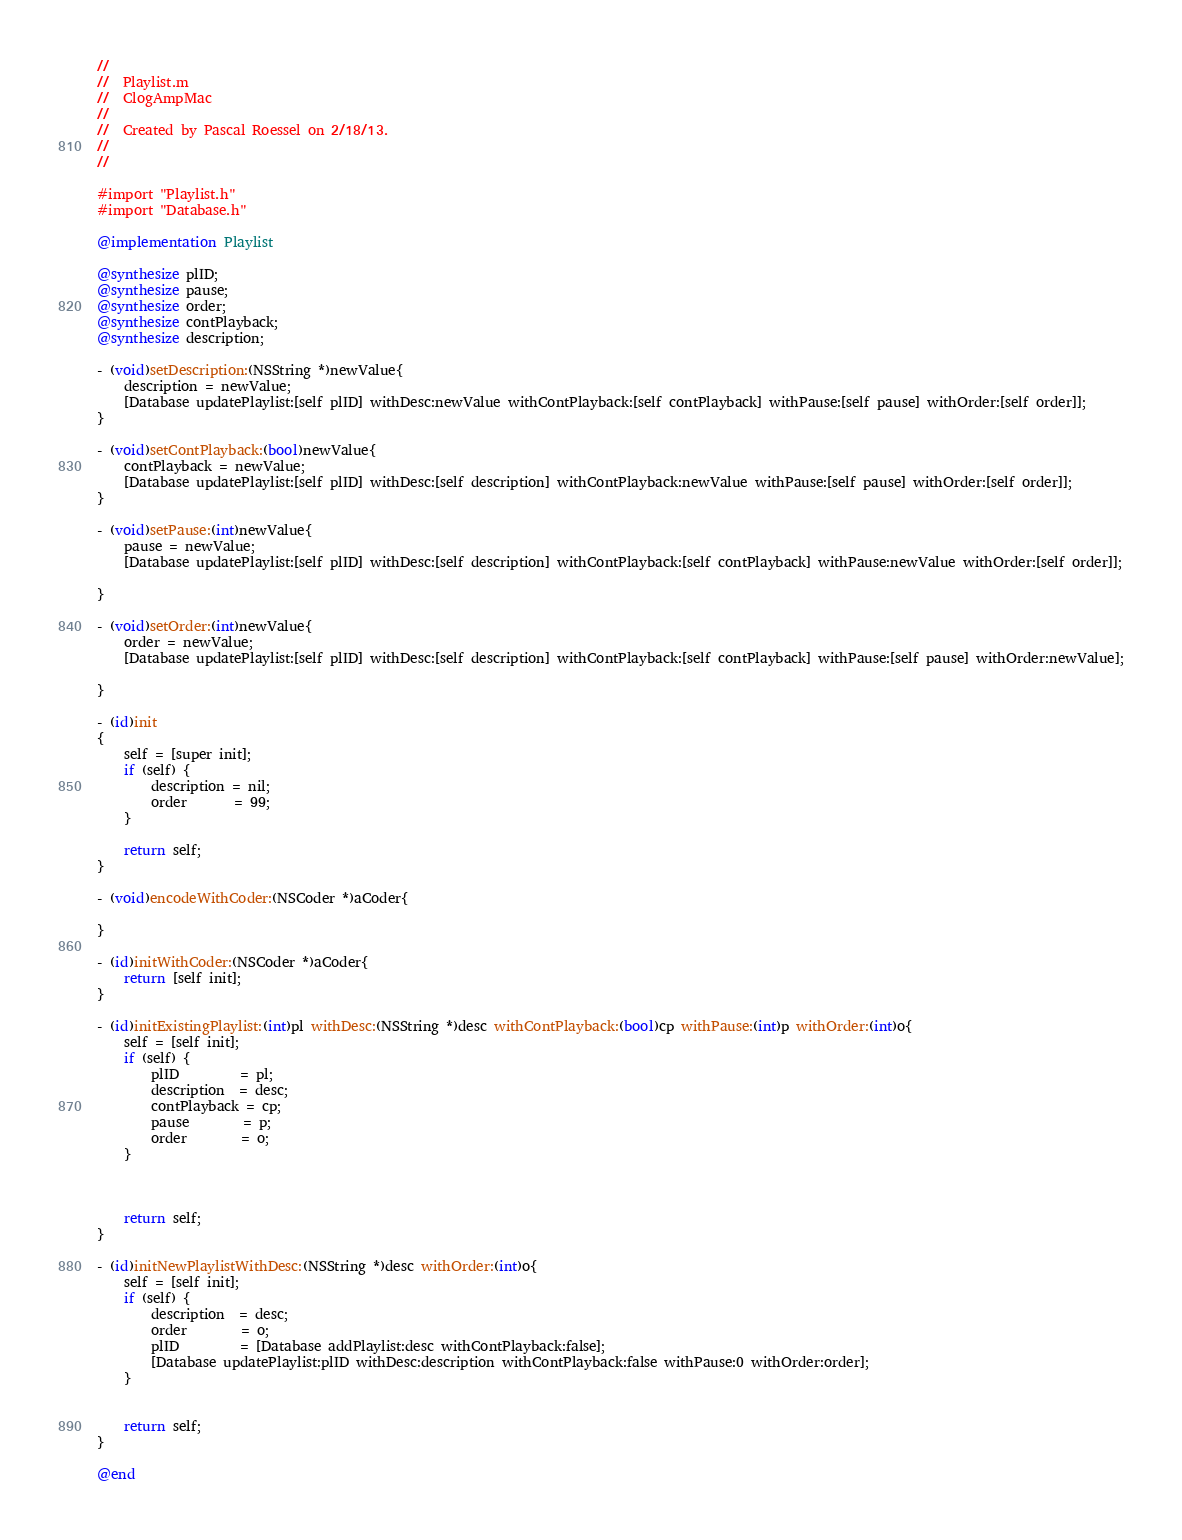Convert code to text. <code><loc_0><loc_0><loc_500><loc_500><_ObjectiveC_>//
//  Playlist.m
//  ClogAmpMac
//
//  Created by Pascal Roessel on 2/18/13.
//
//

#import "Playlist.h"
#import "Database.h"

@implementation Playlist

@synthesize plID;
@synthesize pause;
@synthesize order;
@synthesize contPlayback;
@synthesize description;

- (void)setDescription:(NSString *)newValue{
    description = newValue;
    [Database updatePlaylist:[self plID] withDesc:newValue withContPlayback:[self contPlayback] withPause:[self pause] withOrder:[self order]];
}

- (void)setContPlayback:(bool)newValue{
    contPlayback = newValue;
    [Database updatePlaylist:[self plID] withDesc:[self description] withContPlayback:newValue withPause:[self pause] withOrder:[self order]];
}

- (void)setPause:(int)newValue{
    pause = newValue;
    [Database updatePlaylist:[self plID] withDesc:[self description] withContPlayback:[self contPlayback] withPause:newValue withOrder:[self order]];
    
}

- (void)setOrder:(int)newValue{
    order = newValue;
    [Database updatePlaylist:[self plID] withDesc:[self description] withContPlayback:[self contPlayback] withPause:[self pause] withOrder:newValue];
    
}

- (id)init
{
    self = [super init];
    if (self) {
        description = nil;
        order       = 99;
    }
    
    return self;
}

- (void)encodeWithCoder:(NSCoder *)aCoder{
    
}

- (id)initWithCoder:(NSCoder *)aCoder{
    return [self init];
}

- (id)initExistingPlaylist:(int)pl withDesc:(NSString *)desc withContPlayback:(bool)cp withPause:(int)p withOrder:(int)o{
    self = [self init];
    if (self) {
        plID         = pl;
        description  = desc;
        contPlayback = cp;
        pause        = p;
        order        = o;
    }
    
    
    
    return self;
}

- (id)initNewPlaylistWithDesc:(NSString *)desc withOrder:(int)o{
    self = [self init];
    if (self) {
        description  = desc;
        order        = o;
        plID         = [Database addPlaylist:desc withContPlayback:false];
        [Database updatePlaylist:plID withDesc:description withContPlayback:false withPause:0 withOrder:order];
    }
    
    
    return self;
}

@end
</code> 